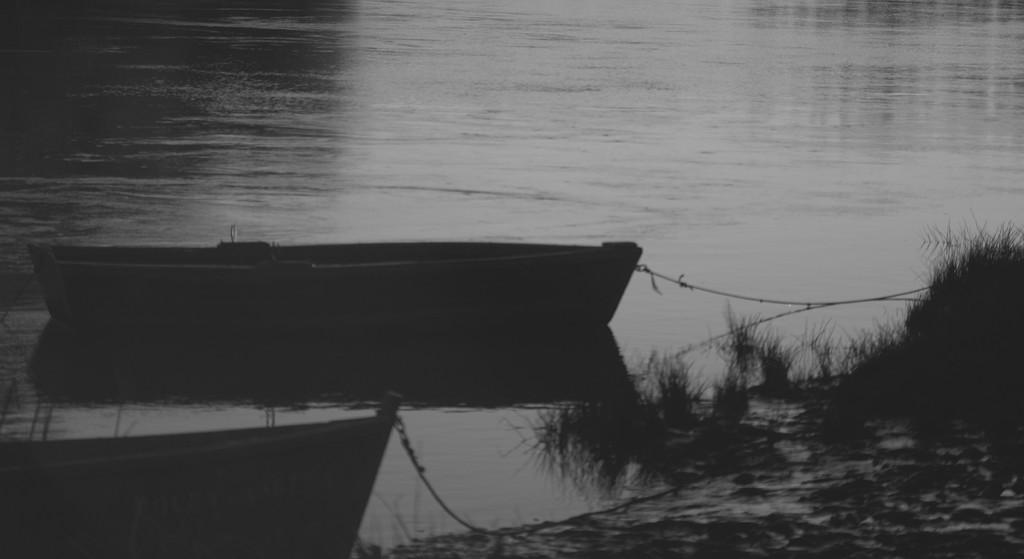What is the color scheme of the image? The image is black and white. What can be seen on the water in the image? There are boats on the water in the image. What objects are visible that might be used for tying or securing? There are ropes visible in the image. What type of vegetation is present in the image? There is grass in the image. How many pies are being served in the park in the image? There are no pies or park present in the image; it features boats on the water, ropes, and grass. What type of cloud can be seen in the image? There are no clouds visible in the image, as it is black and white. 